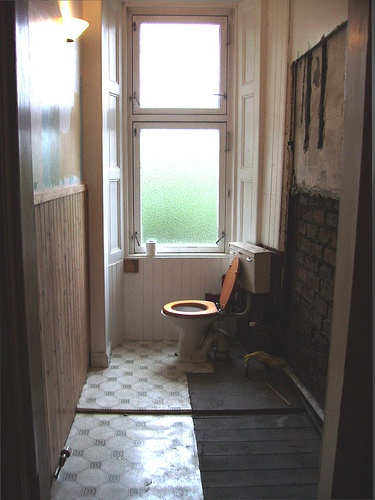Describe the objects in this image and their specific colors. I can see a toilet in black, gray, and brown tones in this image. 